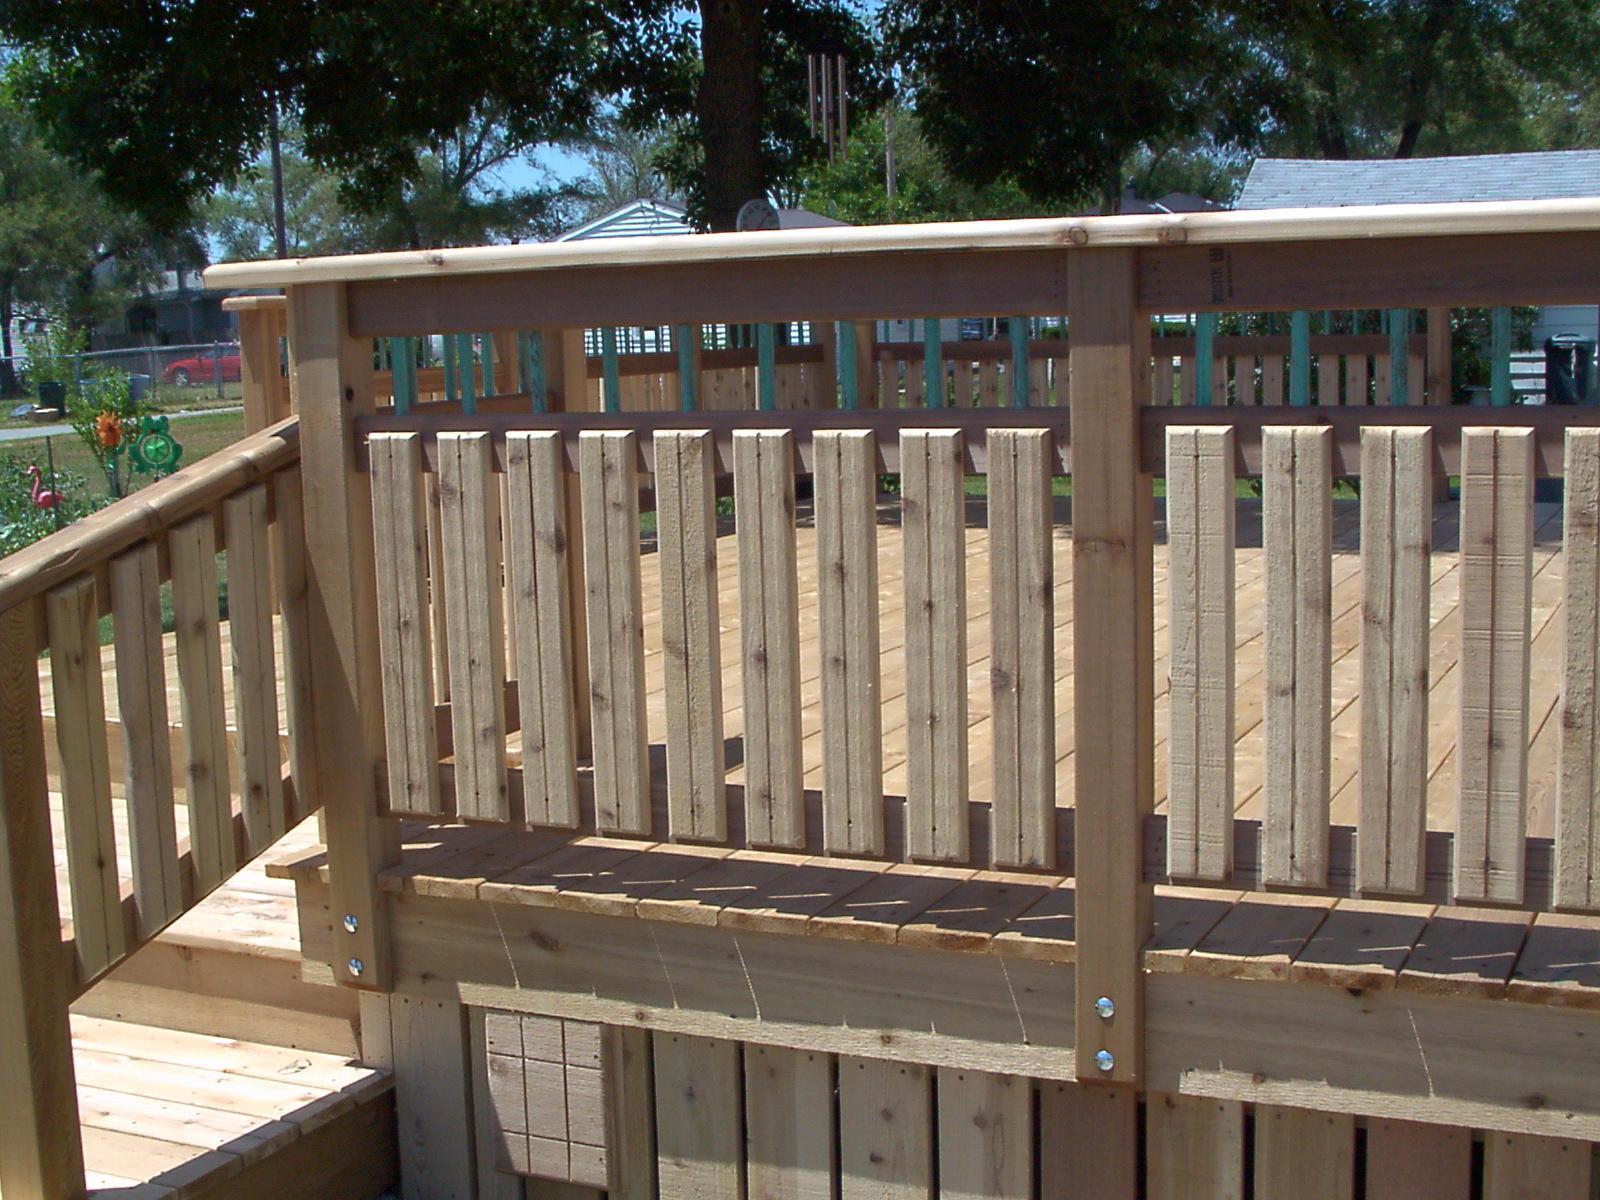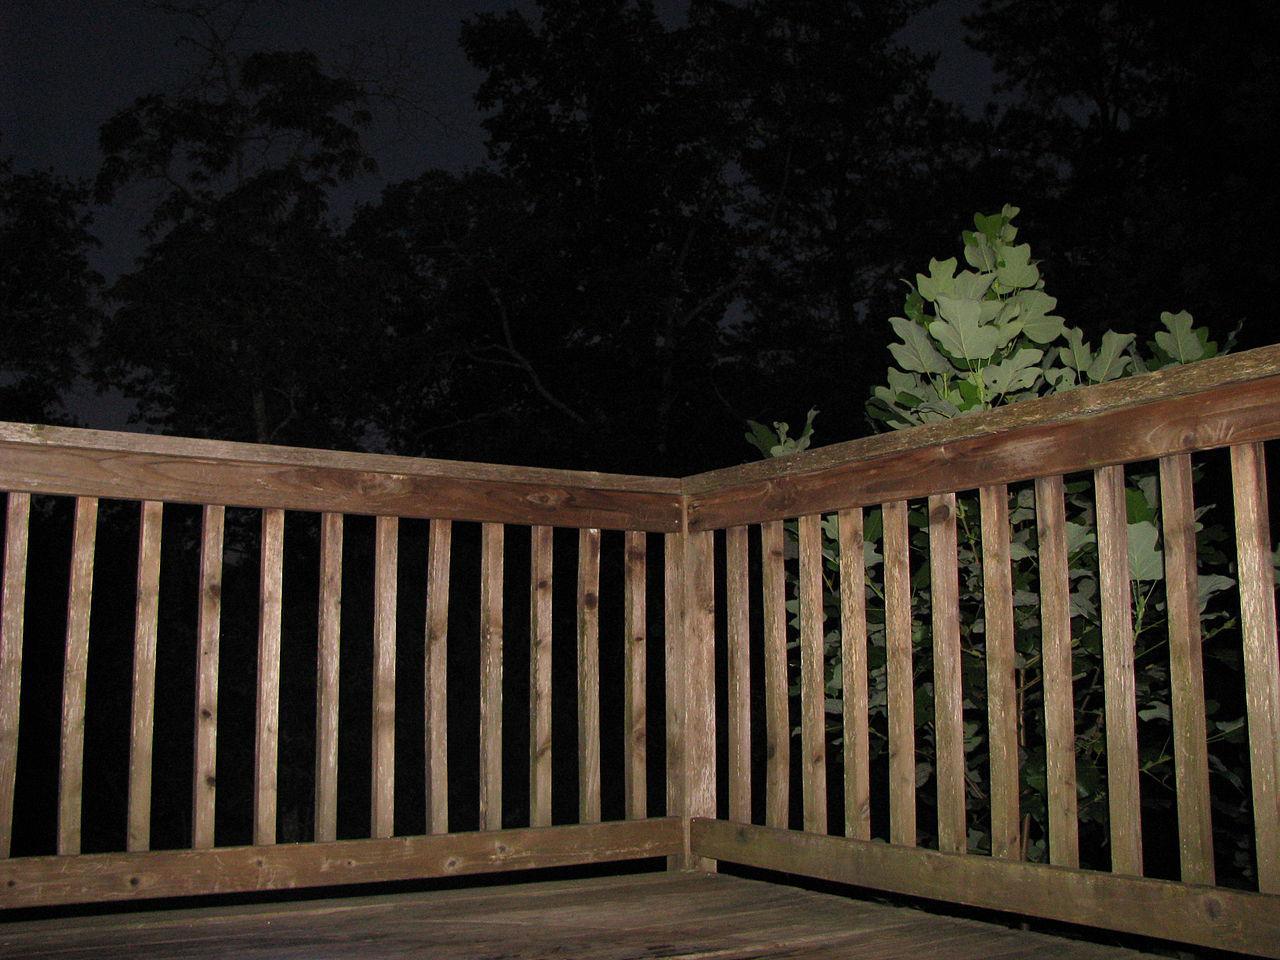The first image is the image on the left, the second image is the image on the right. Evaluate the accuracy of this statement regarding the images: "The right image shows a corner of a wood railed deck with vertical wooden bars that are not casting shadows, and the left image shows a horizontal section of railing with vertical bars.". Is it true? Answer yes or no. Yes. The first image is the image on the left, the second image is the image on the right. Evaluate the accuracy of this statement regarding the images: "In one of the images, you can see a blacktop road in the background.". Is it true? Answer yes or no. No. 